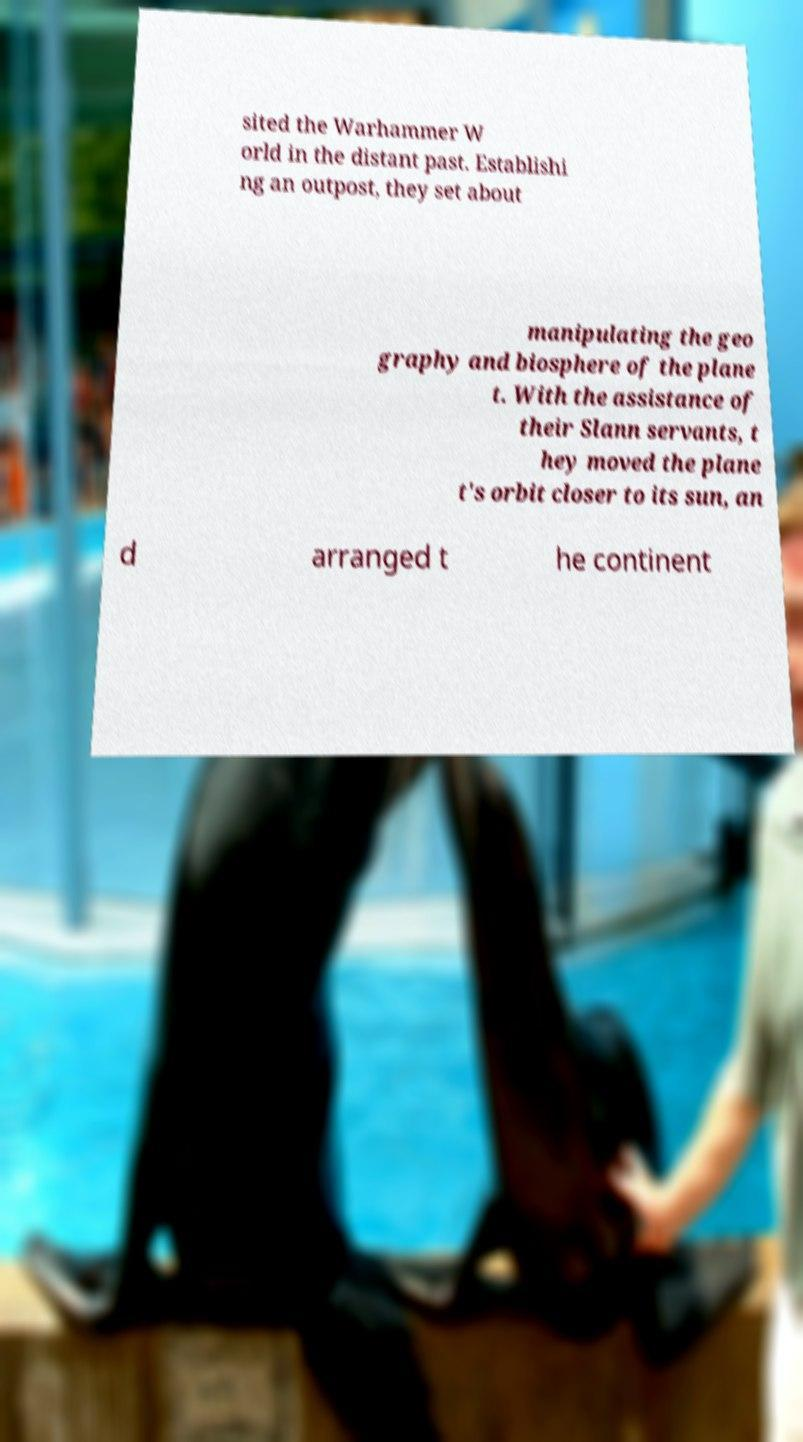For documentation purposes, I need the text within this image transcribed. Could you provide that? sited the Warhammer W orld in the distant past. Establishi ng an outpost, they set about manipulating the geo graphy and biosphere of the plane t. With the assistance of their Slann servants, t hey moved the plane t's orbit closer to its sun, an d arranged t he continent 